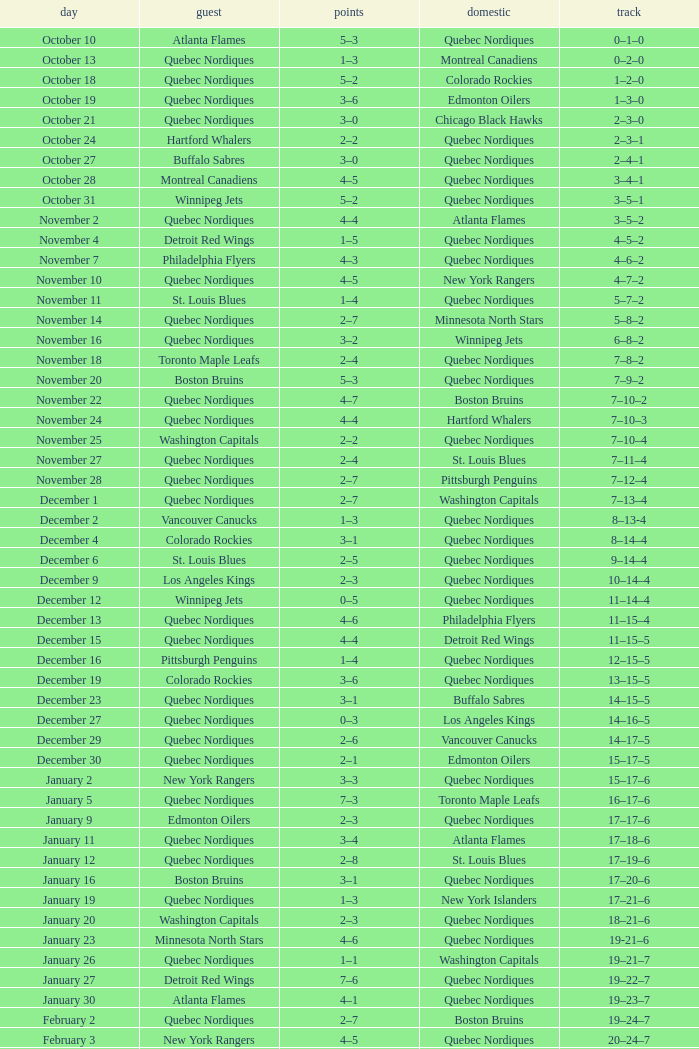Which Home has a Record of 11–14–4? Quebec Nordiques. 